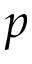Convert formula to latex. <formula><loc_0><loc_0><loc_500><loc_500>p</formula> 